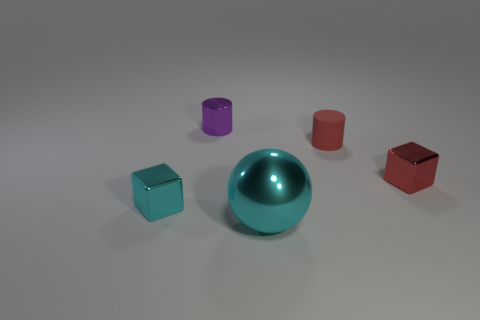Are there any other things that are made of the same material as the red cylinder?
Offer a terse response. No. The red rubber thing has what shape?
Offer a terse response. Cylinder. What is the material of the cyan thing that is on the left side of the ball?
Your answer should be compact. Metal. How big is the cyan object that is right of the cyan object that is on the left side of the cyan metallic object to the right of the purple cylinder?
Your answer should be compact. Large. Is the material of the small cube that is on the left side of the big metallic ball the same as the cylinder right of the purple metallic cylinder?
Your response must be concise. No. How many other objects are the same color as the shiny cylinder?
Make the answer very short. 0. What number of objects are either things that are behind the red matte thing or large balls in front of the purple cylinder?
Offer a terse response. 2. There is a block left of the tiny cube that is right of the purple thing; how big is it?
Provide a succinct answer. Small. How big is the matte object?
Provide a succinct answer. Small. There is a cube on the right side of the large object; is its color the same as the cylinder on the left side of the small red cylinder?
Give a very brief answer. No. 